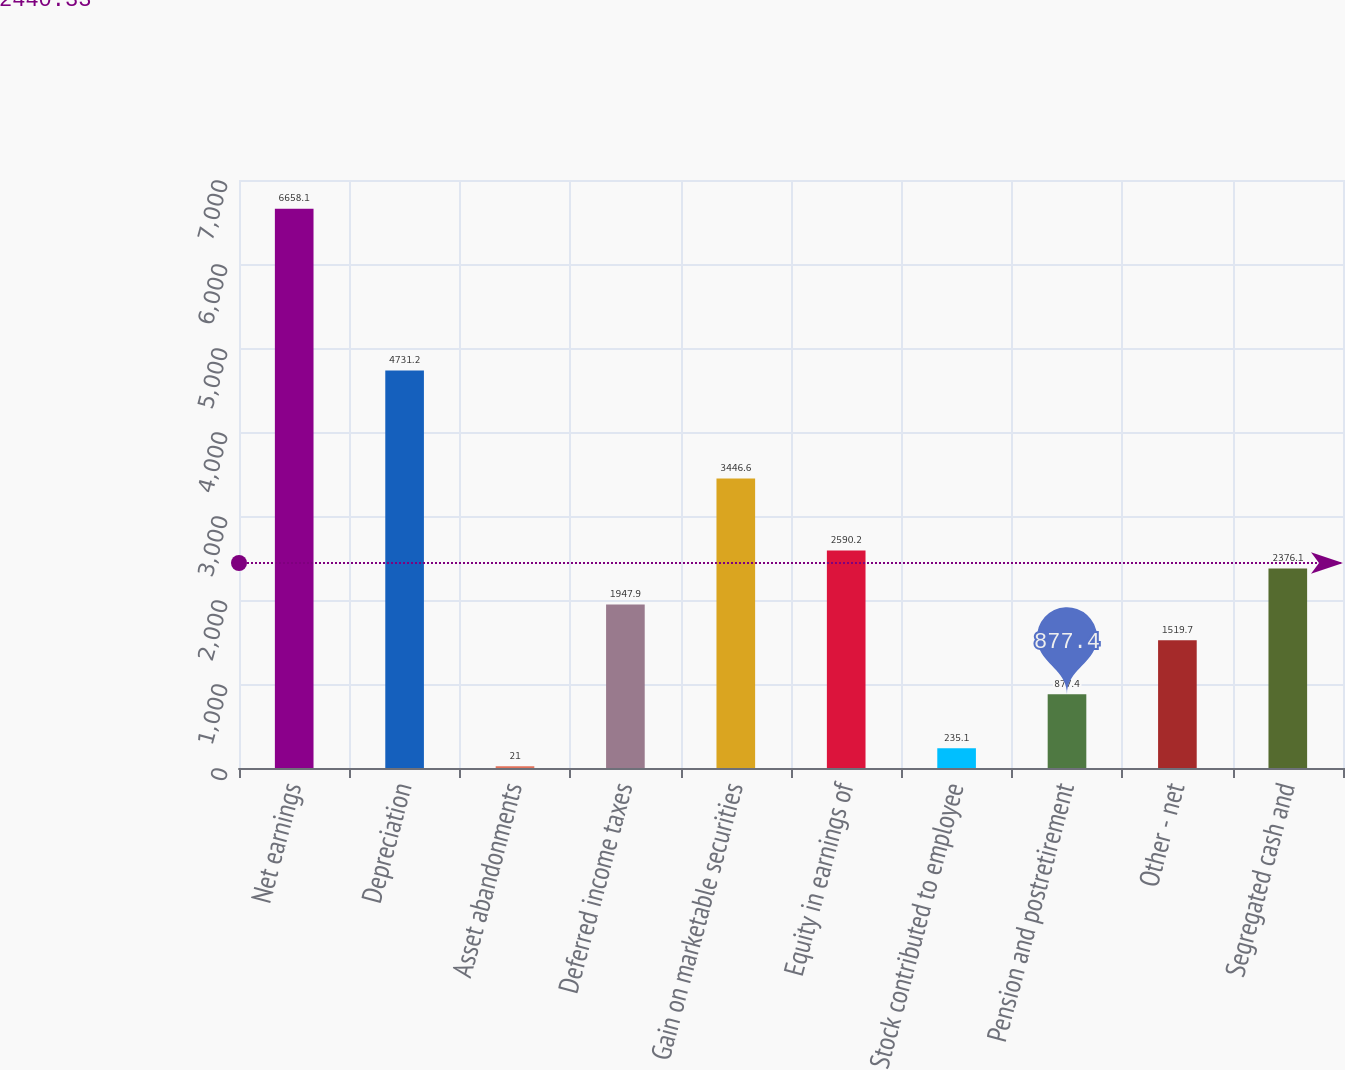Convert chart to OTSL. <chart><loc_0><loc_0><loc_500><loc_500><bar_chart><fcel>Net earnings<fcel>Depreciation<fcel>Asset abandonments<fcel>Deferred income taxes<fcel>Gain on marketable securities<fcel>Equity in earnings of<fcel>Stock contributed to employee<fcel>Pension and postretirement<fcel>Other - net<fcel>Segregated cash and<nl><fcel>6658.1<fcel>4731.2<fcel>21<fcel>1947.9<fcel>3446.6<fcel>2590.2<fcel>235.1<fcel>877.4<fcel>1519.7<fcel>2376.1<nl></chart> 